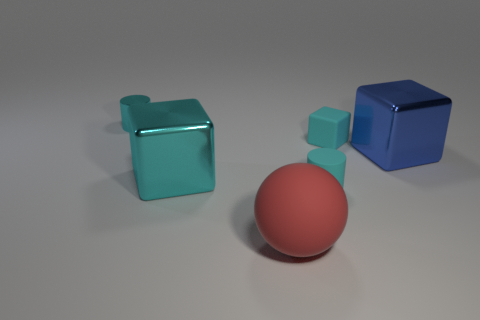Add 4 cyan matte cylinders. How many objects exist? 10 Subtract all balls. How many objects are left? 5 Subtract all blue things. Subtract all tiny cyan objects. How many objects are left? 2 Add 1 cyan blocks. How many cyan blocks are left? 3 Add 3 big matte spheres. How many big matte spheres exist? 4 Subtract 1 cyan cylinders. How many objects are left? 5 